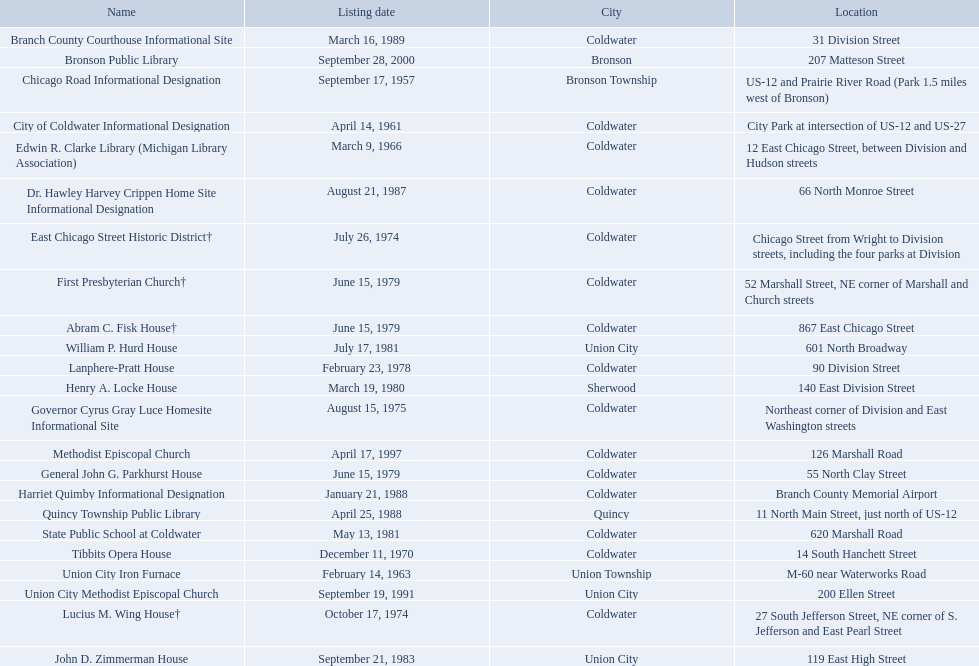In branch co. mi what historic sites are located on a near a highway? Chicago Road Informational Designation, City of Coldwater Informational Designation, Quincy Township Public Library, Union City Iron Furnace. Of the historic sites ins branch co. near highways, which ones are near only us highways? Chicago Road Informational Designation, City of Coldwater Informational Designation, Quincy Township Public Library. Which historical sites in branch co. are near only us highways and are not a building? Chicago Road Informational Designation, City of Coldwater Informational Designation. Which non-building historical sites in branch county near a us highways is closest to bronson? Chicago Road Informational Designation. 